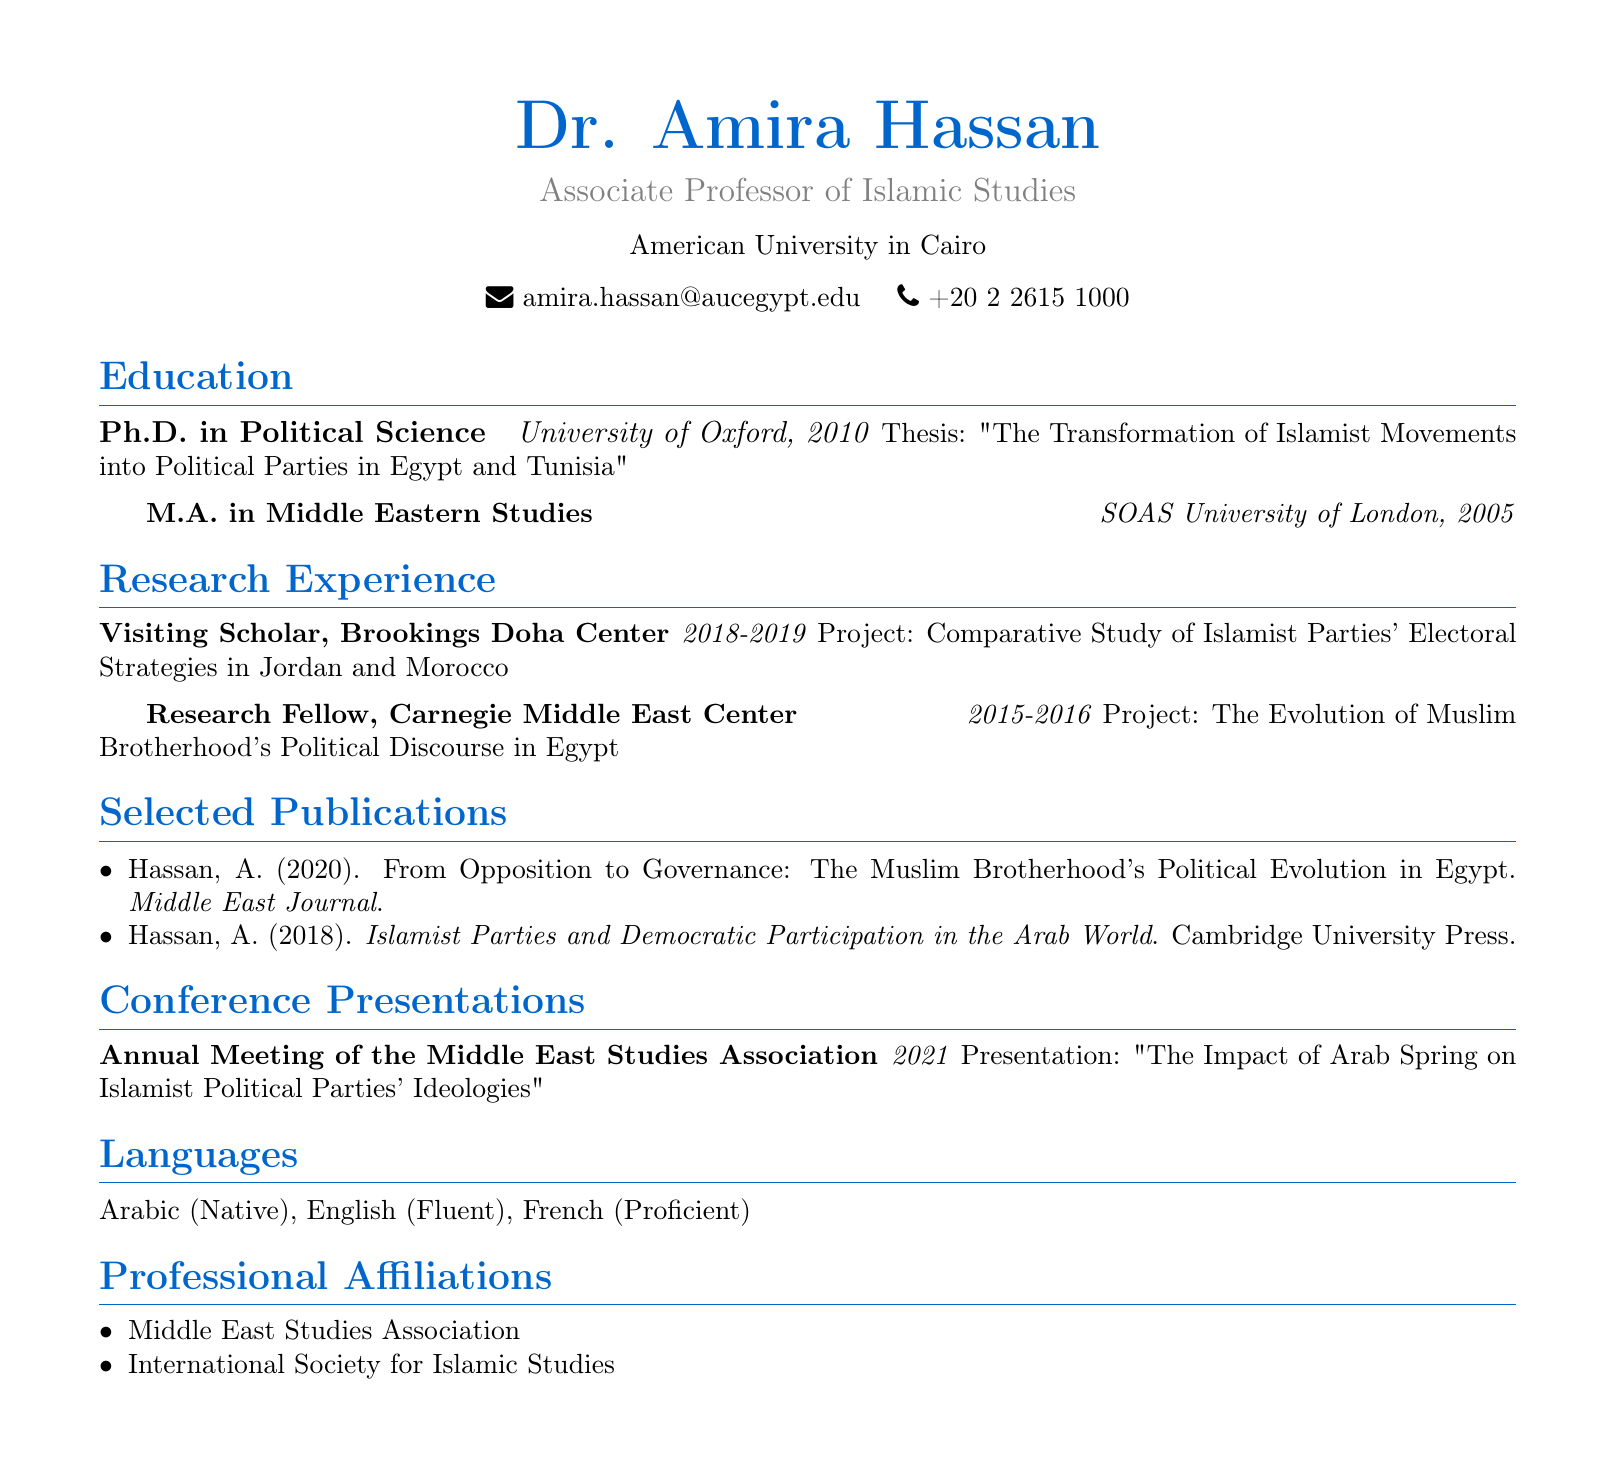What is the name of the associate professor? The document provides the personal information section, where the name "Dr. Amira Hassan" is listed as the associate professor.
Answer: Dr. Amira Hassan What is the title of Dr. Amira Hassan? The document specifies that she holds the title of "Associate Professor of Islamic Studies."
Answer: Associate Professor of Islamic Studies In which year did Dr. Amira Hassan obtain her Ph.D.? The education section outlines her academic achievements, indicating the year she completed her Ph.D. as 2010.
Answer: 2010 What was the focus of her doctoral thesis? The thesis title is mentioned as "The Transformation of Islamist Movements into Political Parties in Egypt and Tunisia."
Answer: The Transformation of Islamist Movements into Political Parties in Egypt and Tunisia Which institution was Dr. Amira Hassan affiliated with as a Visiting Scholar? The research experience section indicates her position as Visiting Scholar at the "Brookings Doha Center."
Answer: Brookings Doha Center Name one publication by Dr. Amira Hassan. The selected publications section includes several works, where one is titled "From Opposition to Governance: The Muslim Brotherhood's Political Evolution in Egypt."
Answer: From Opposition to Governance: The Muslim Brotherhood's Political Evolution in Egypt In what year did she present at the Annual Meeting of the Middle East Studies Association? The conference presentations section states that she presented in the year 2021.
Answer: 2021 What languages does Dr. Amira Hassan speak? The languages section lists three languages, indicating her proficiency: "Arabic, English, French."
Answer: Arabic, English, French Which professional affiliation is listed in her CV? The professional affiliations section mentions several organizations, including the "Middle East Studies Association."
Answer: Middle East Studies Association 